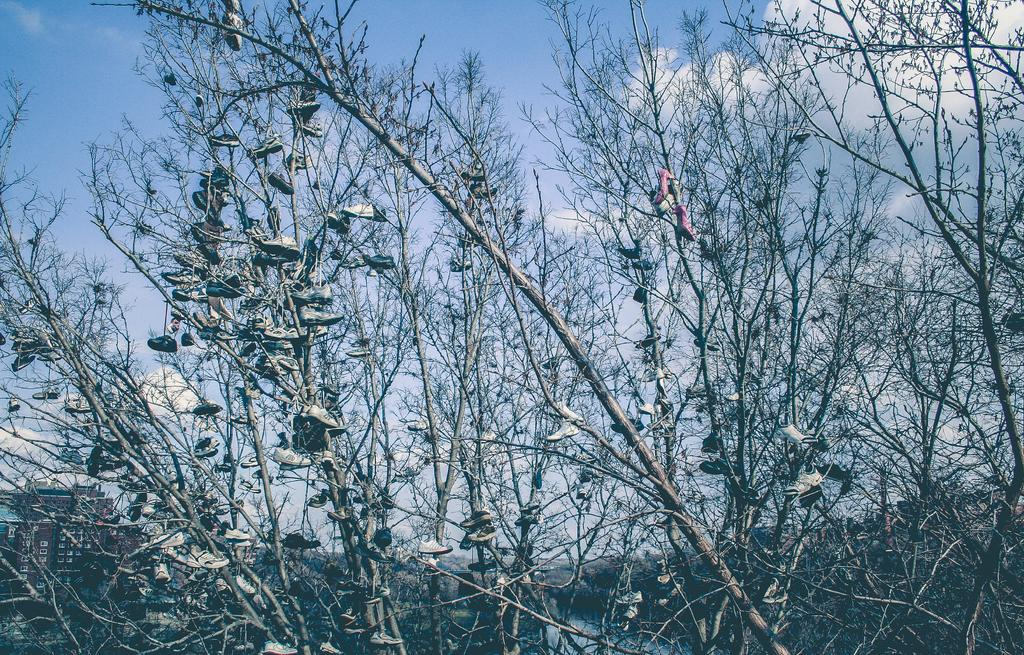What type of vegetation can be seen in the image? There are trees in the image. What is visible in the background of the image? The sky is visible in the background of the image. How would you describe the sky in the image? The sky appears to be clear in the image. How many sheep are visible in the image? There are no sheep present in the image. What shape is the ball in the image? There is no ball present in the image. 